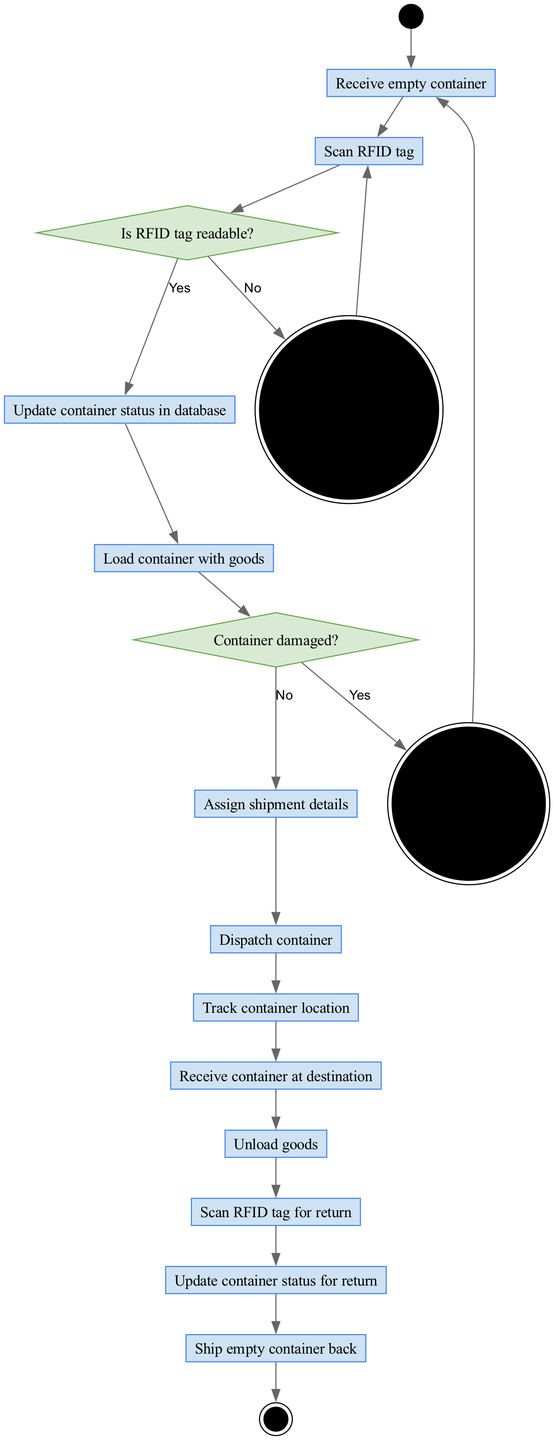What is the first activity in the diagram? The diagram indicates the sequence of activities, starting from the initial node. The first activity listed is "Receive empty container."
Answer: Receive empty container How many decision nodes are present in the diagram? The diagram contains two decision nodes that determine the flow based on specific conditions related to the RFID tag and the condition of the container.
Answer: 2 What happens if the RFID tag is not readable? According to the diagram, if the RFID tag is unreadable, the process follows the "no" path of the decision node, which leads to "Replace RFID tag."
Answer: Replace RFID tag What will occur after unloading goods? After "Unload goods," the subsequent activity specified in the diagram is to "Scan RFID tag for return."
Answer: Scan RFID tag for return What is the outcome when the container is damaged? The flow indicates that if the container is damaged, the process leads to the action "Send for repair."
Answer: Send for repair Which activity comes directly after "Scan RFID tag"? The diagram shows that after "Scan RFID tag," the next activity is "Update container status in database."
Answer: Update container status in database What is the last activity before the final node? The activity right before the final node is labeled "Ship empty container back," marking the end of the process.
Answer: Ship empty container back What decision leads to sending a container for repair? The decision node in the diagram asks if the "Container damaged?" If the answer is "yes," it leads to "Send for repair."
Answer: Send for repair How many activities are listed in total? Total counting all activities from the initial receipt of the container to the final dispatch shows there are 12 activities listed in the diagram.
Answer: 12 